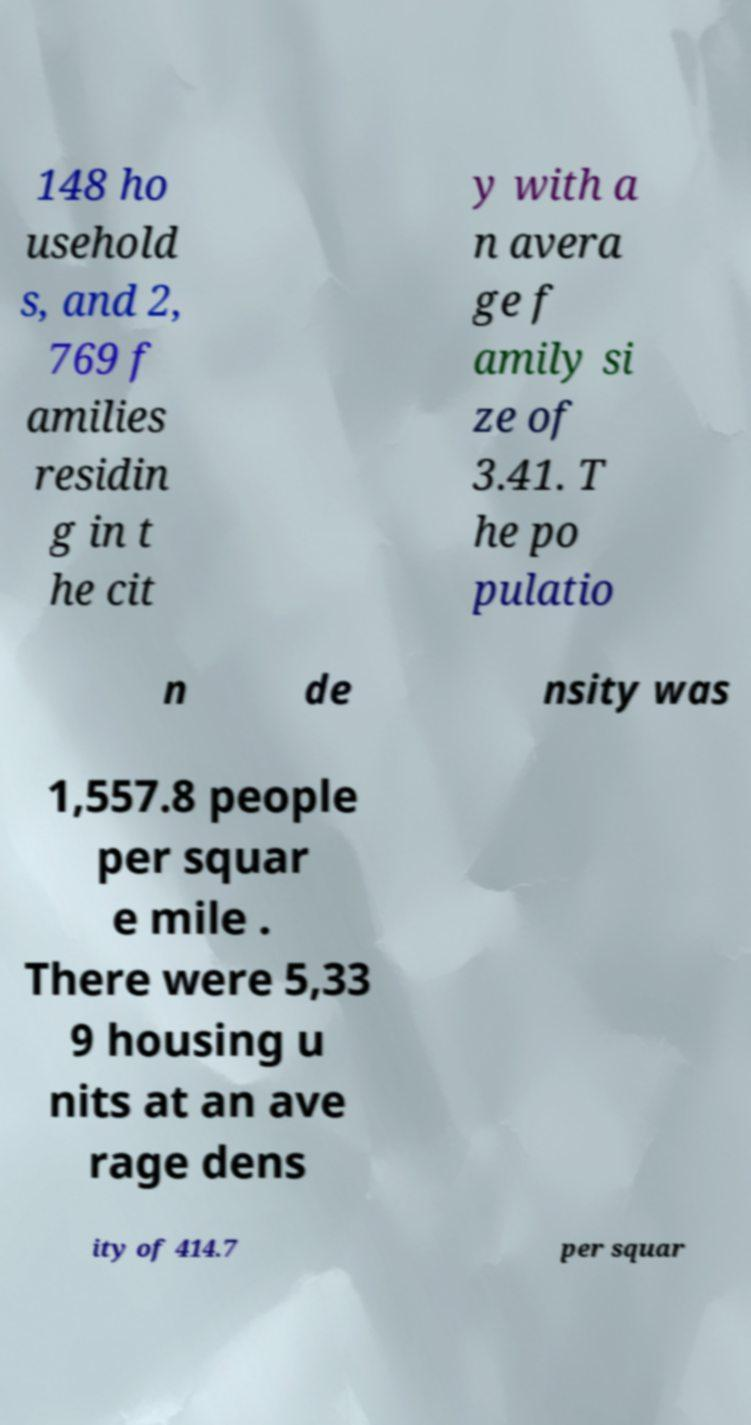What messages or text are displayed in this image? I need them in a readable, typed format. 148 ho usehold s, and 2, 769 f amilies residin g in t he cit y with a n avera ge f amily si ze of 3.41. T he po pulatio n de nsity was 1,557.8 people per squar e mile . There were 5,33 9 housing u nits at an ave rage dens ity of 414.7 per squar 